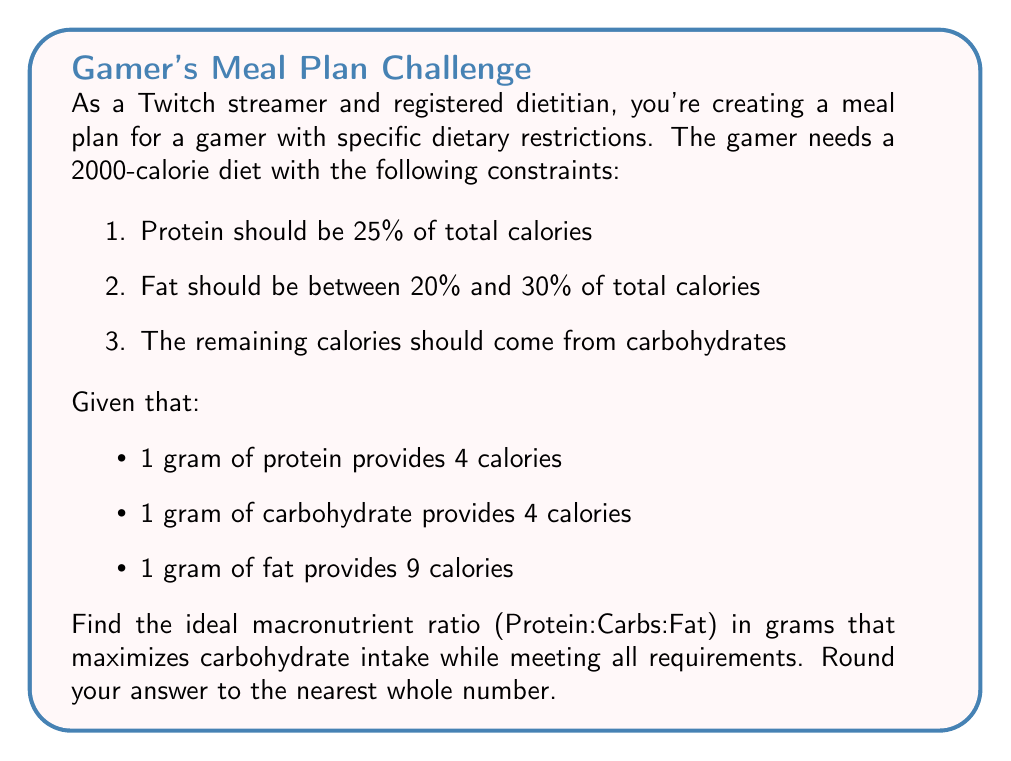Teach me how to tackle this problem. Let's approach this step-by-step:

1) First, calculate the calories from protein:
   $25\% \text{ of } 2000 = 0.25 \times 2000 = 500 \text{ calories}$

2) Convert protein calories to grams:
   $500 \text{ calories} \div 4 \text{ calories/g} = 125 \text{ g of protein}$

3) For fat, we want to minimize it to maximize carbs. So we'll use the lower limit of 20%:
   $20\% \text{ of } 2000 = 0.20 \times 2000 = 400 \text{ calories}$

4) Convert fat calories to grams:
   $400 \text{ calories} \div 9 \text{ calories/g} = 44.44 \text{ g of fat}$

5) Calculate remaining calories for carbohydrates:
   $2000 - 500 - 400 = 1100 \text{ calories}$

6) Convert carb calories to grams:
   $1100 \text{ calories} \div 4 \text{ calories/g} = 275 \text{ g of carbohydrates}$

7) The macronutrient ratio in grams is therefore:
   Protein : Carbs : Fat = 125 : 275 : 44.44

8) Rounding to the nearest whole number:
   Protein : Carbs : Fat = 125 : 275 : 44
Answer: The ideal macronutrient ratio in grams is 125:275:44 (Protein:Carbs:Fat). 